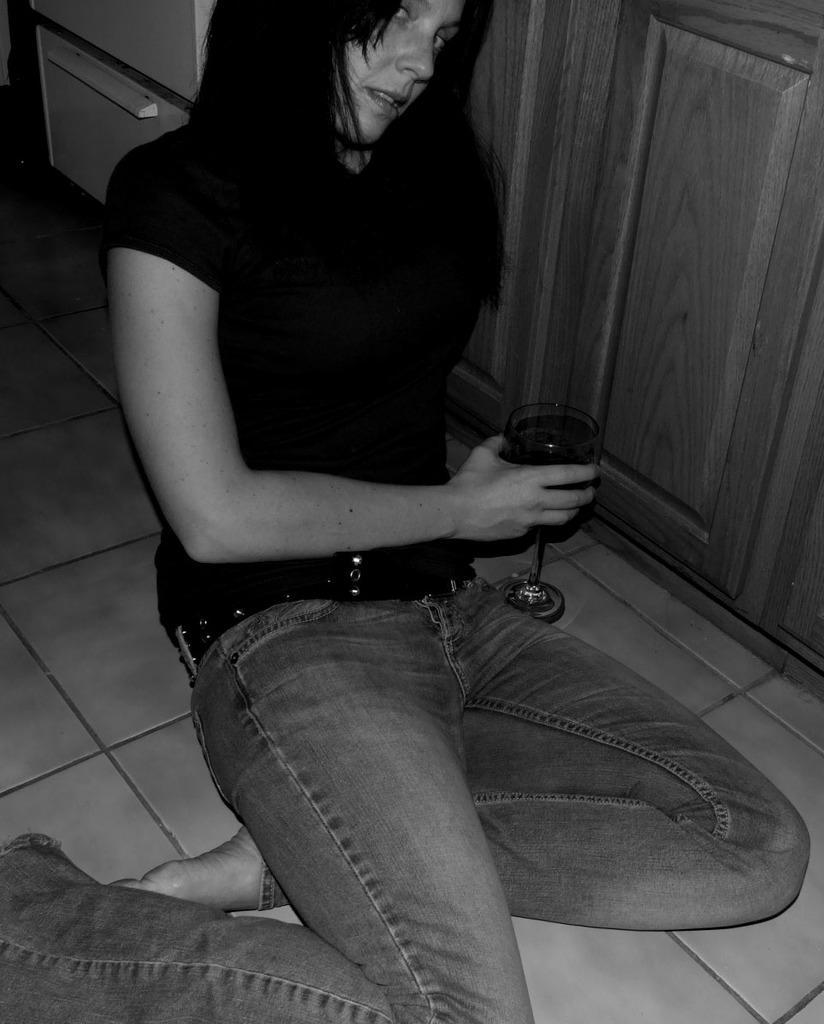Please provide a concise description of this image. In this image I can see a woman is sitting on floor. I can also see she is holding a glass. 